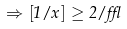<formula> <loc_0><loc_0><loc_500><loc_500>\Rightarrow [ 1 / x ] \geq 2 / \epsilon</formula> 